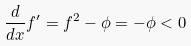<formula> <loc_0><loc_0><loc_500><loc_500>\frac { d } { d x } f ^ { \prime } = f ^ { 2 } - \phi = - \phi < 0</formula> 